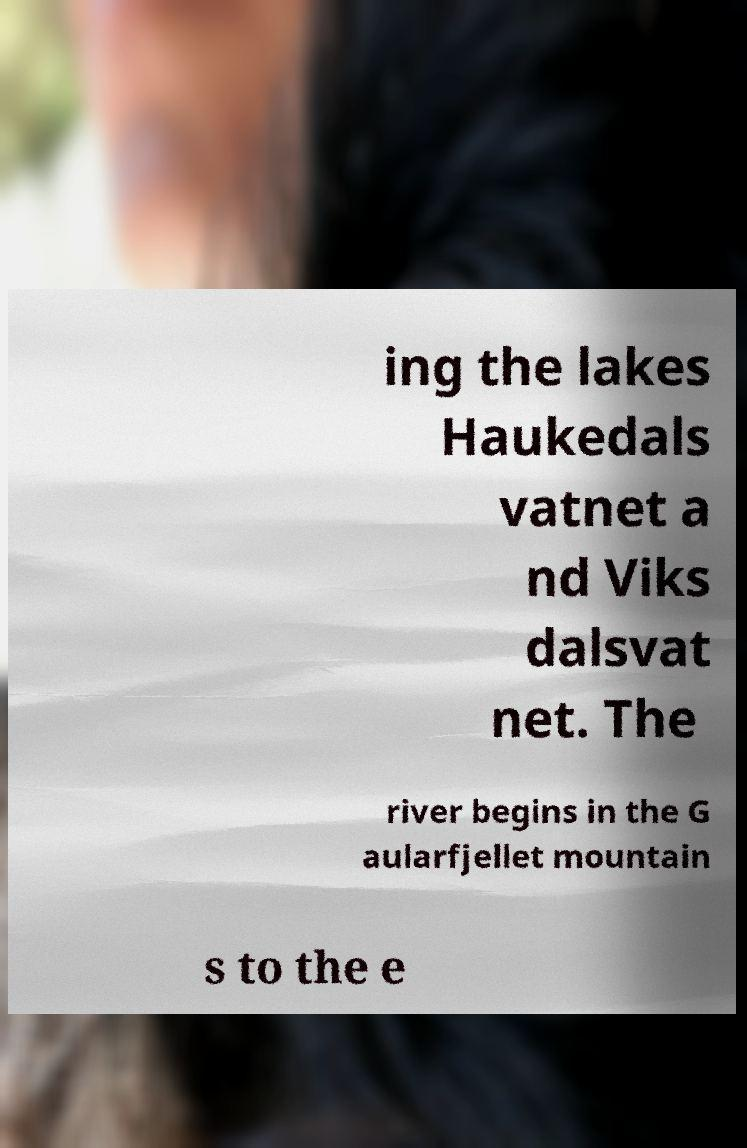Can you read and provide the text displayed in the image?This photo seems to have some interesting text. Can you extract and type it out for me? ing the lakes Haukedals vatnet a nd Viks dalsvat net. The river begins in the G aularfjellet mountain s to the e 